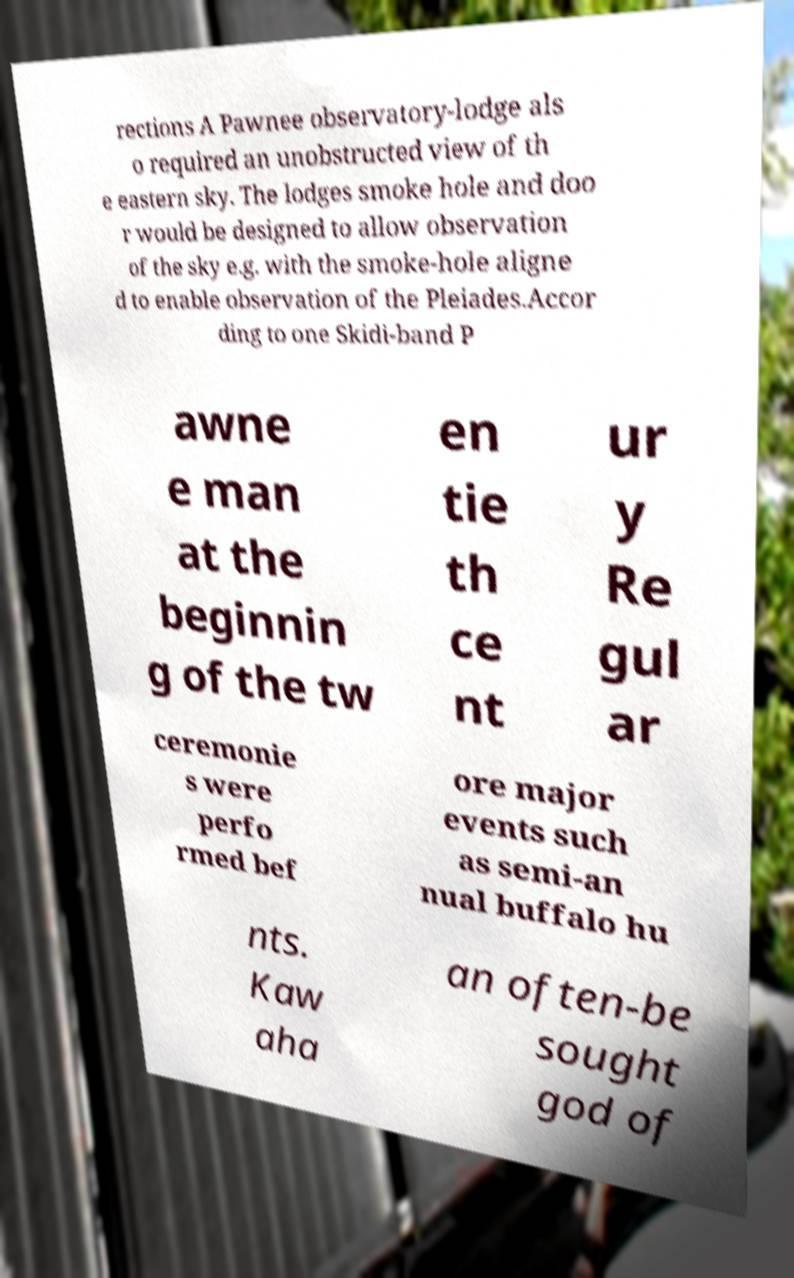Could you extract and type out the text from this image? rections A Pawnee observatory-lodge als o required an unobstructed view of th e eastern sky. The lodges smoke hole and doo r would be designed to allow observation of the sky e.g. with the smoke-hole aligne d to enable observation of the Pleiades.Accor ding to one Skidi-band P awne e man at the beginnin g of the tw en tie th ce nt ur y Re gul ar ceremonie s were perfo rmed bef ore major events such as semi-an nual buffalo hu nts. Kaw aha an often-be sought god of 